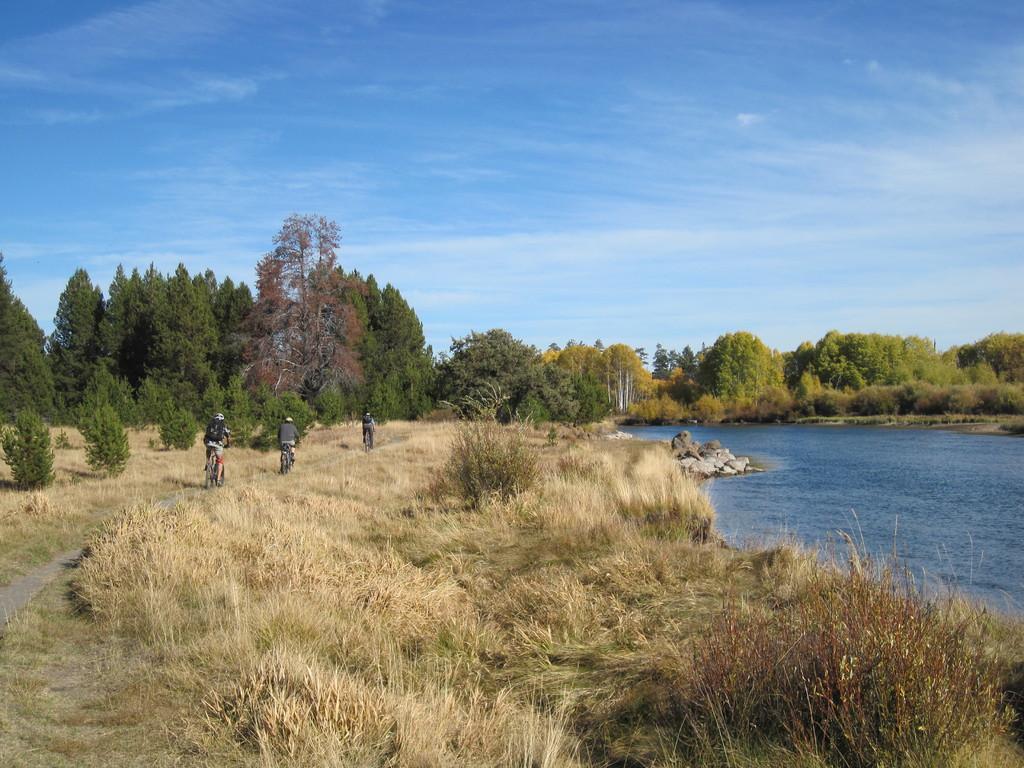Can you describe this image briefly? In the foreground of the image we can see grass. In the middle of the image we can see some water body, trees, rocks and some persons are riding bicycles. On the top of the image we can see the sky. 